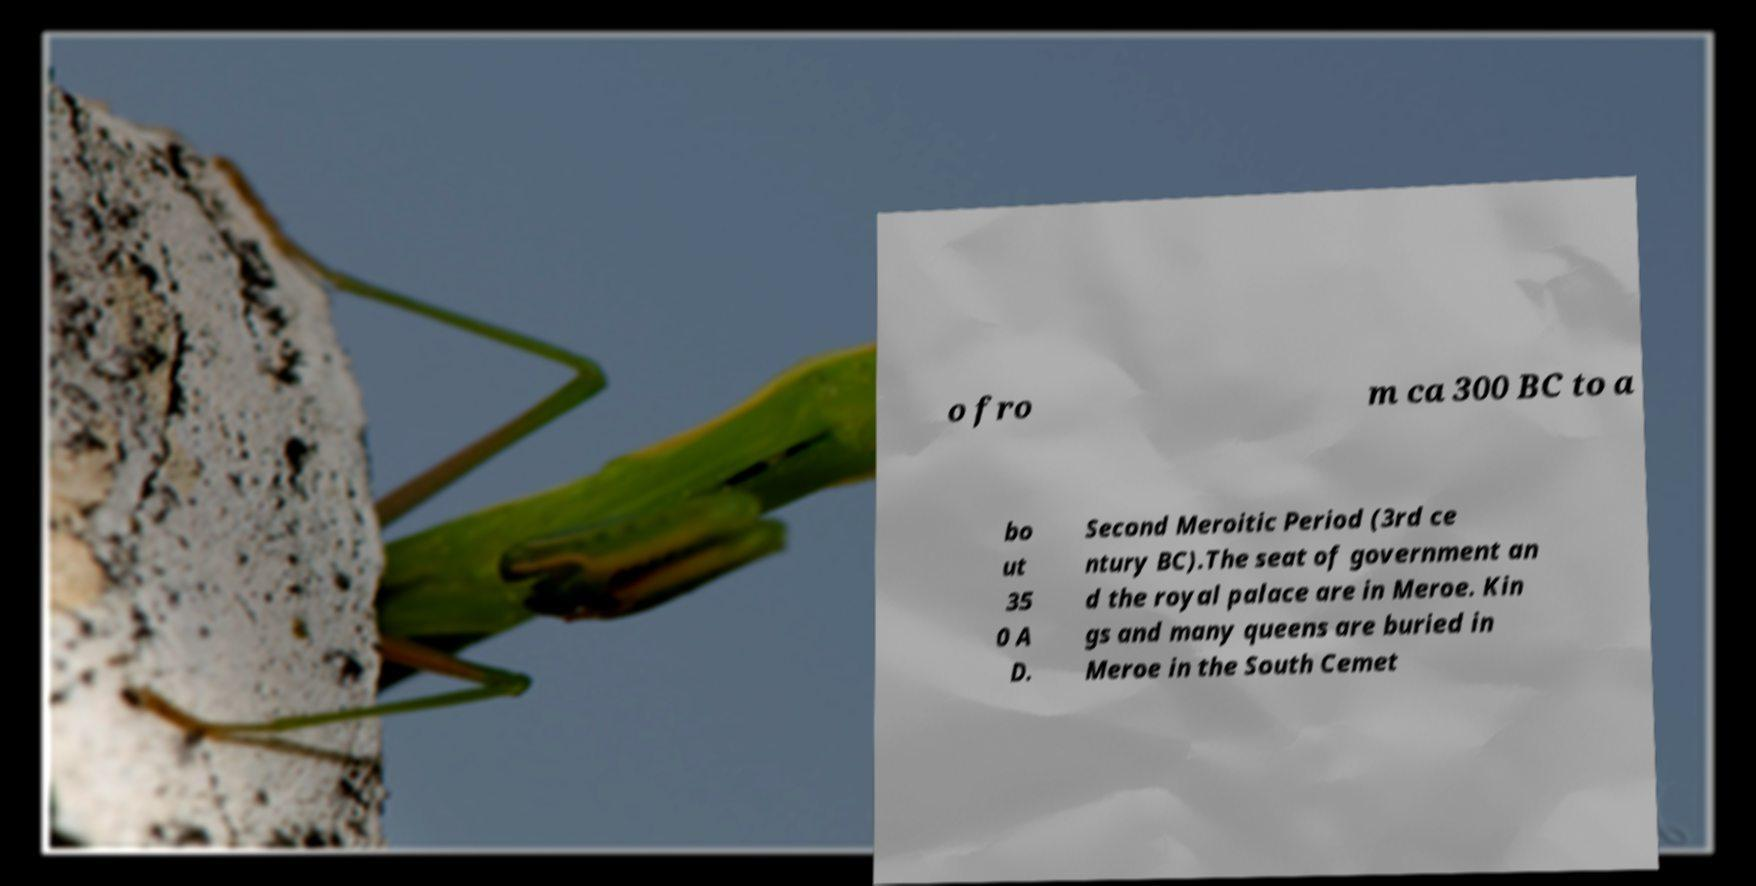Please identify and transcribe the text found in this image. o fro m ca 300 BC to a bo ut 35 0 A D. Second Meroitic Period (3rd ce ntury BC).The seat of government an d the royal palace are in Meroe. Kin gs and many queens are buried in Meroe in the South Cemet 